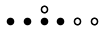<formula> <loc_0><loc_0><loc_500><loc_500>\begin{smallmatrix} & & \circ \\ \bullet & \bullet & \bullet & \bullet & \circ & \circ & \\ \end{smallmatrix}</formula> 